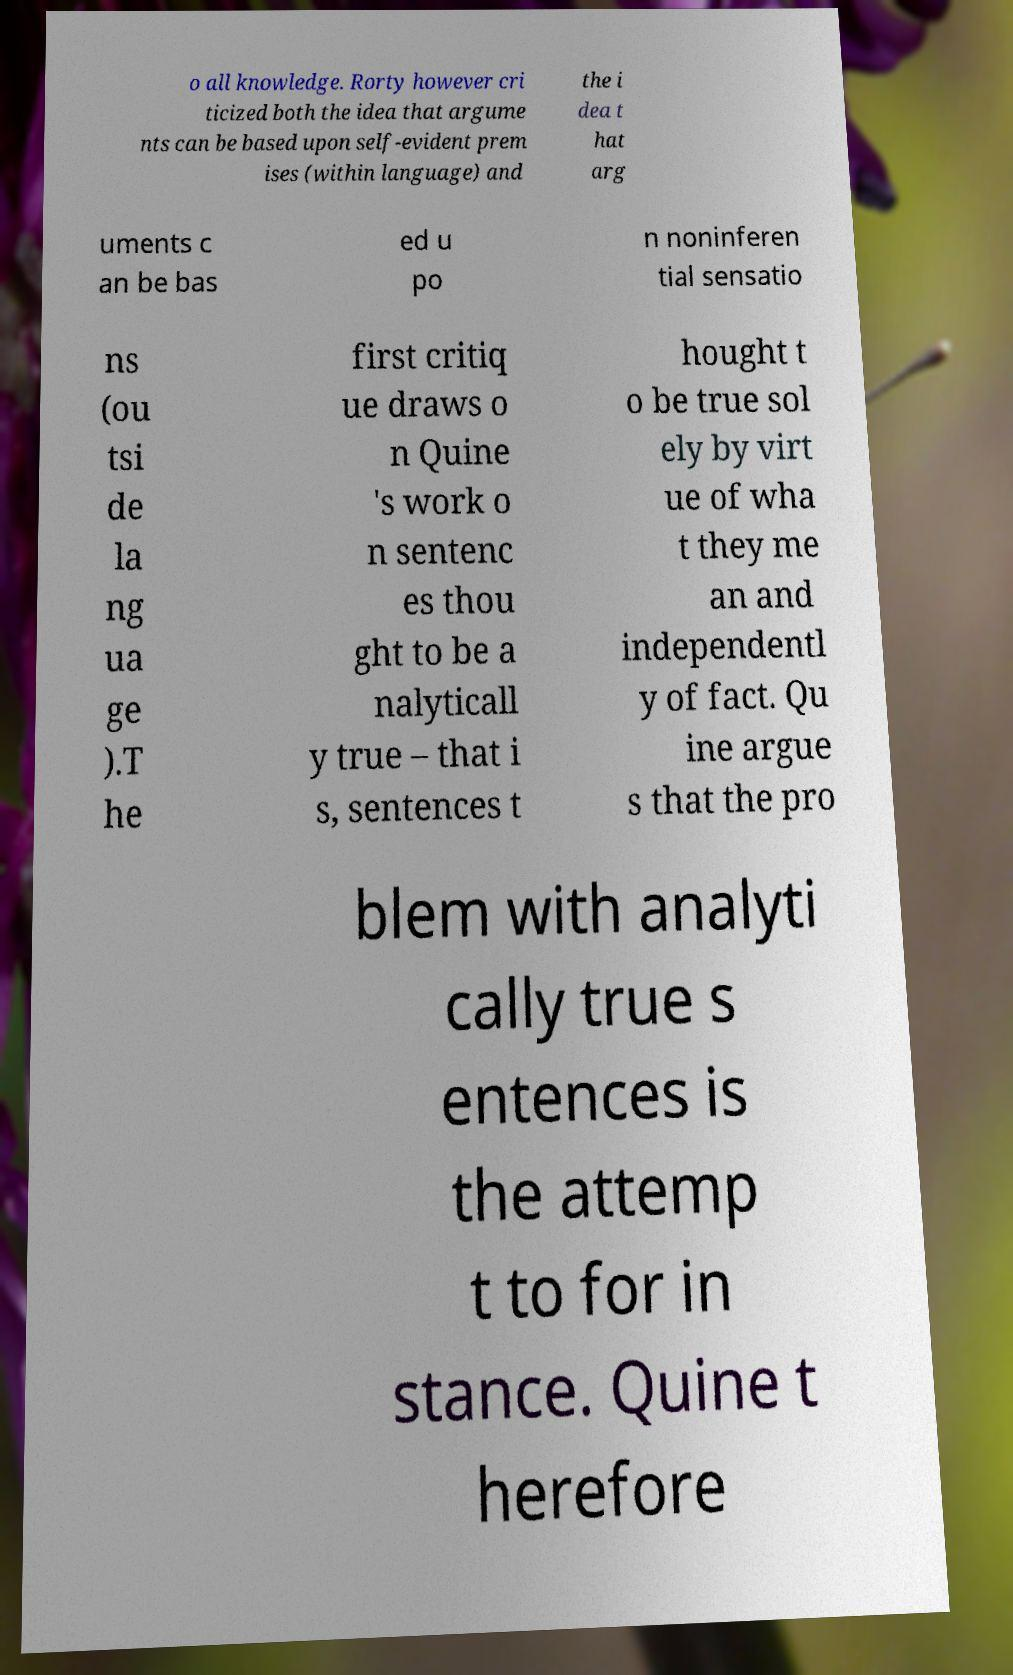Please read and relay the text visible in this image. What does it say? o all knowledge. Rorty however cri ticized both the idea that argume nts can be based upon self-evident prem ises (within language) and the i dea t hat arg uments c an be bas ed u po n noninferen tial sensatio ns (ou tsi de la ng ua ge ).T he first critiq ue draws o n Quine 's work o n sentenc es thou ght to be a nalyticall y true – that i s, sentences t hought t o be true sol ely by virt ue of wha t they me an and independentl y of fact. Qu ine argue s that the pro blem with analyti cally true s entences is the attemp t to for in stance. Quine t herefore 